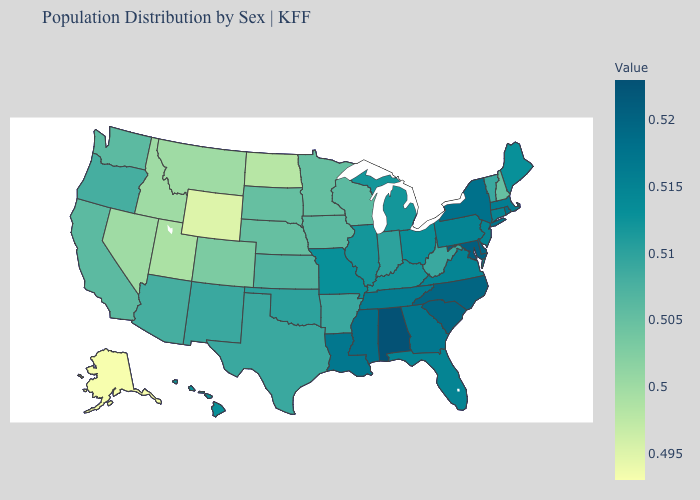Does Florida have the lowest value in the South?
Short answer required. No. Does the map have missing data?
Be succinct. No. Does Alabama have the highest value in the USA?
Short answer required. Yes. Which states have the highest value in the USA?
Quick response, please. Alabama. Which states have the highest value in the USA?
Keep it brief. Alabama. Which states hav the highest value in the South?
Write a very short answer. Alabama. 